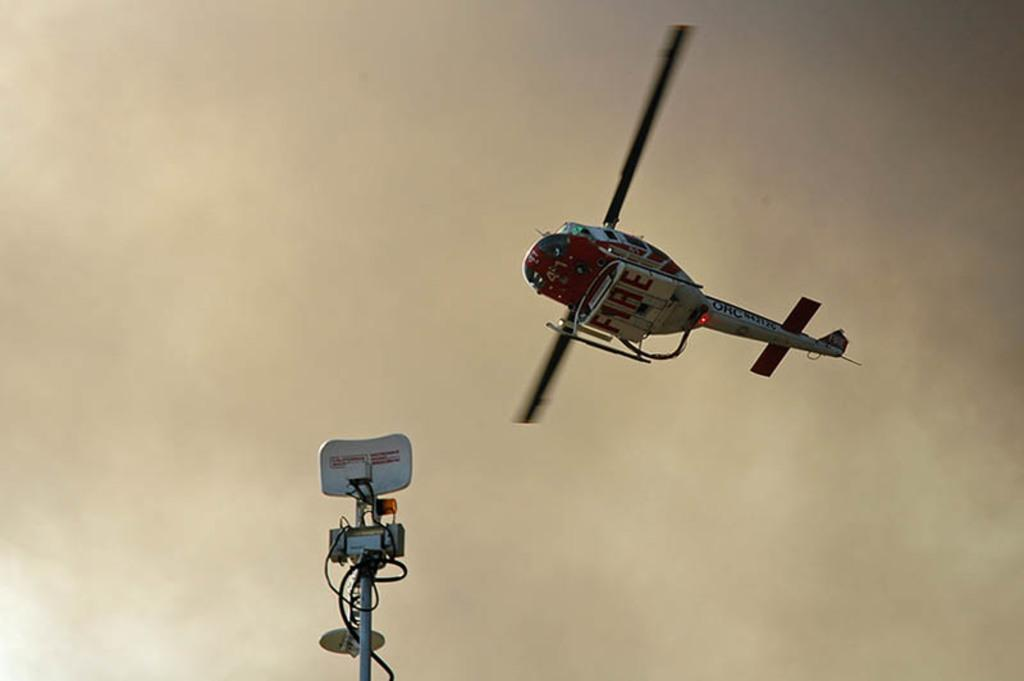<image>
Summarize the visual content of the image. A helicopter says fire on the bottom of it. 